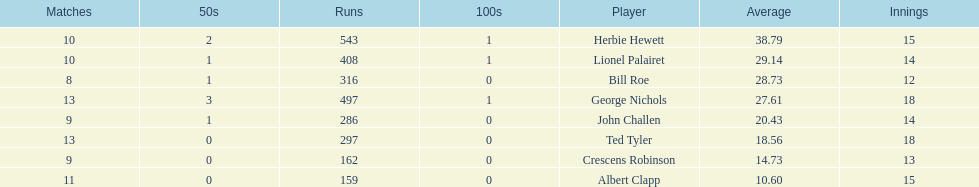What is the lowest amount of runs anyone possesses? 159. 